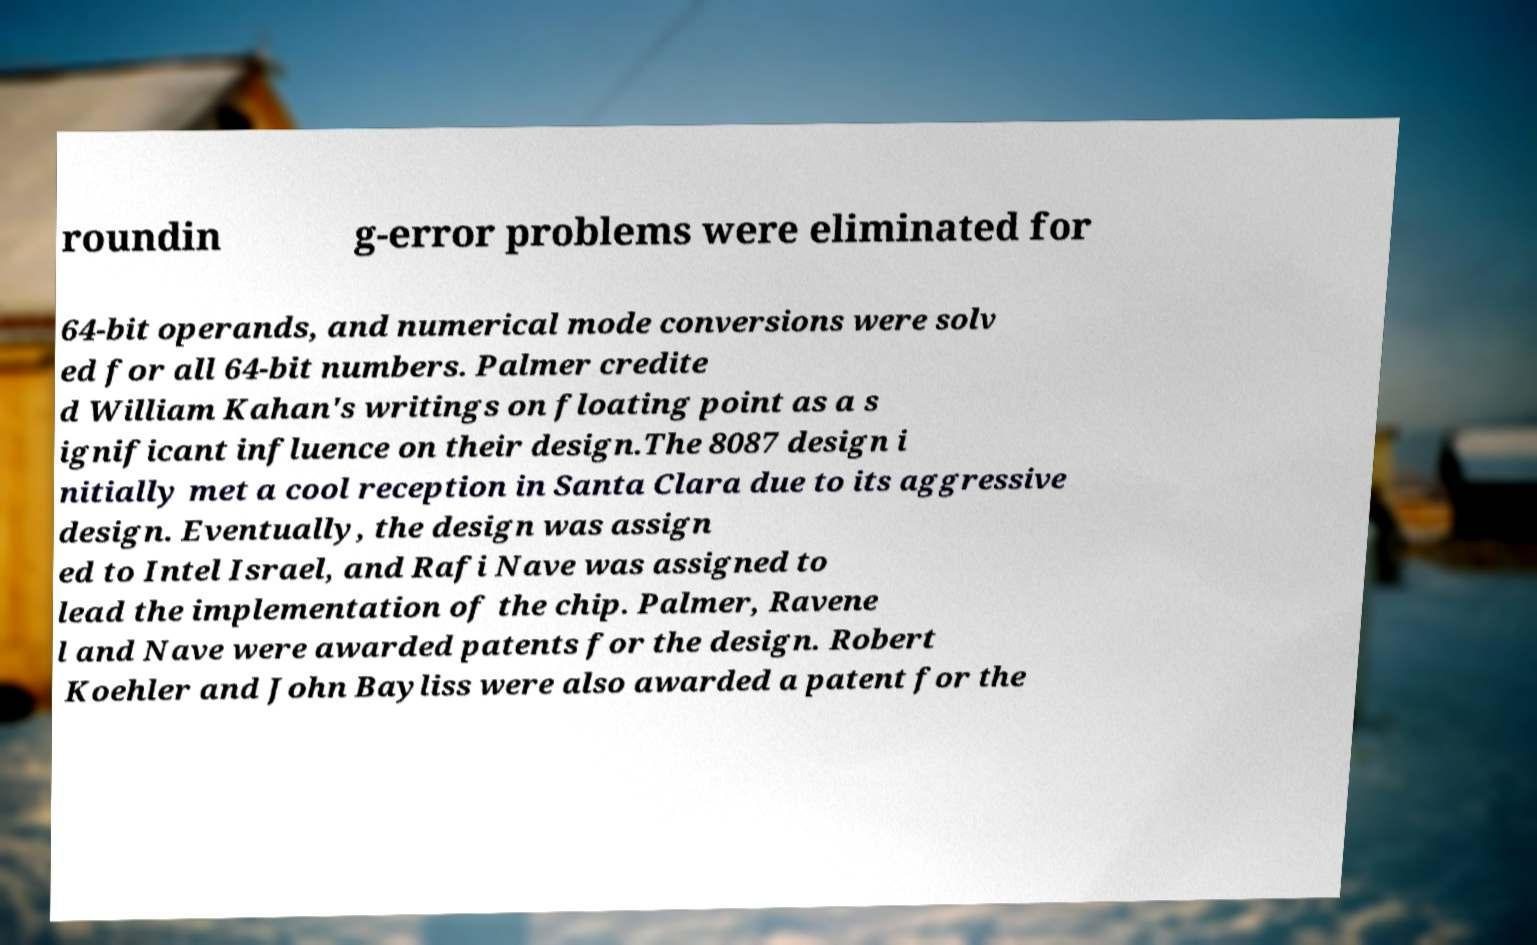Can you accurately transcribe the text from the provided image for me? roundin g-error problems were eliminated for 64-bit operands, and numerical mode conversions were solv ed for all 64-bit numbers. Palmer credite d William Kahan's writings on floating point as a s ignificant influence on their design.The 8087 design i nitially met a cool reception in Santa Clara due to its aggressive design. Eventually, the design was assign ed to Intel Israel, and Rafi Nave was assigned to lead the implementation of the chip. Palmer, Ravene l and Nave were awarded patents for the design. Robert Koehler and John Bayliss were also awarded a patent for the 